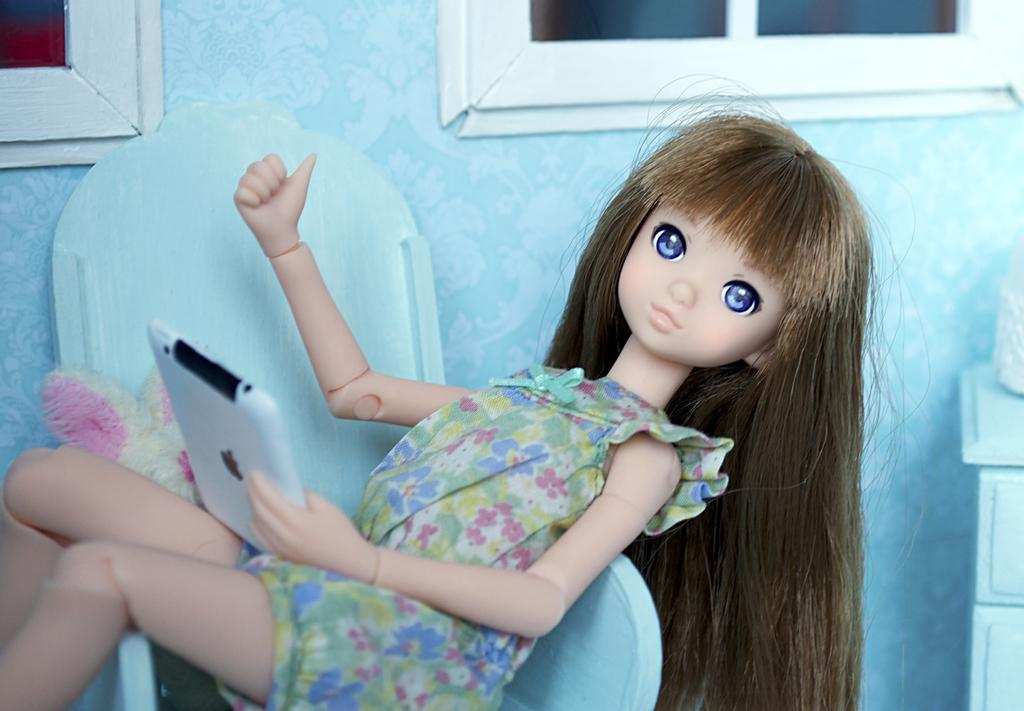What object is present in the image that is not a person or a part of the background? There is a toy in the image. Where is the toy located in the image? The toy is sitting in a chair. What is the toy holding in its hand? The toy is holding a tablet in its hand. What can be seen behind the toy in the image? There is a wall in the background of the image. What type of quill is the toy using to write on the tablet in the image? There is no quill present in the image; the toy is holding a tablet, not a writing instrument. 